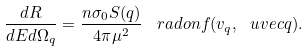<formula> <loc_0><loc_0><loc_500><loc_500>\frac { d R } { d E d \Omega _ { q } } = \frac { n \sigma _ { 0 } S ( q ) } { 4 \pi \mu ^ { 2 } } \, \ r a d o n { f } ( v _ { q } , \ u v e c { q } ) .</formula> 